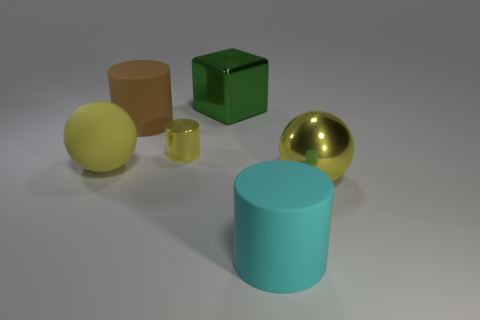Add 2 yellow shiny objects. How many objects exist? 8 Subtract all blocks. How many objects are left? 5 Add 1 big shiny blocks. How many big shiny blocks exist? 2 Subtract 0 blue cubes. How many objects are left? 6 Subtract all cyan metal cubes. Subtract all large yellow things. How many objects are left? 4 Add 2 big cyan matte cylinders. How many big cyan matte cylinders are left? 3 